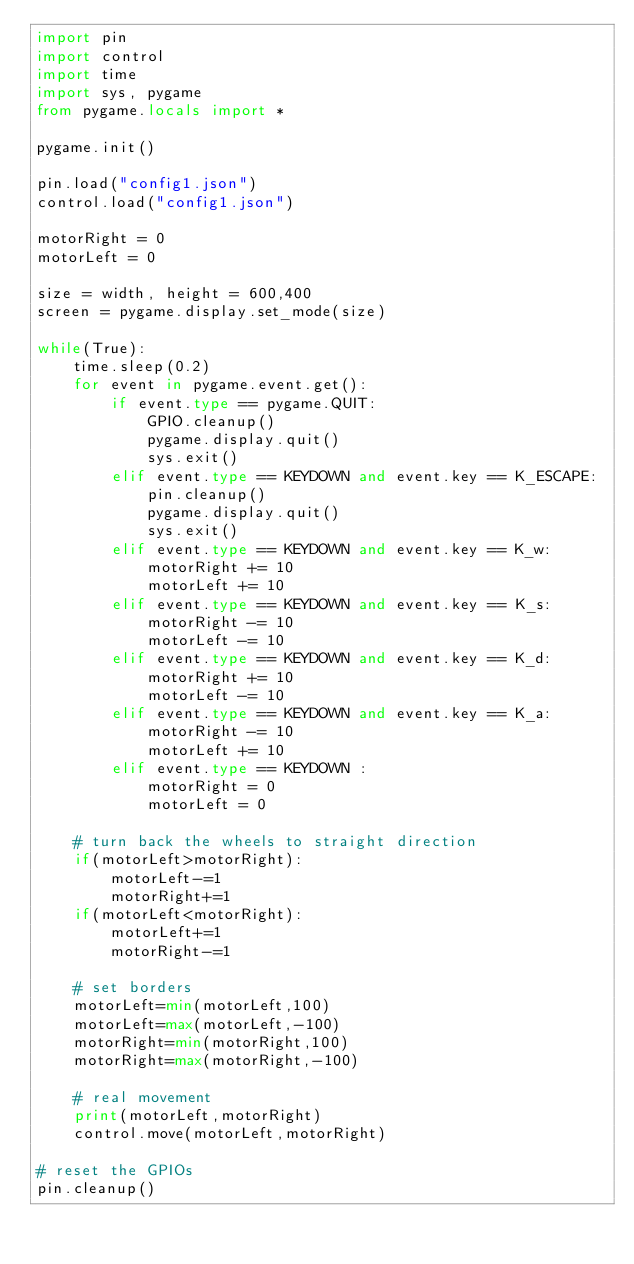<code> <loc_0><loc_0><loc_500><loc_500><_Python_>import pin
import control
import time
import sys, pygame
from pygame.locals import *

pygame.init()

pin.load("config1.json")
control.load("config1.json")

motorRight = 0
motorLeft = 0

size = width, height = 600,400
screen = pygame.display.set_mode(size)

while(True):        
    time.sleep(0.2)
    for event in pygame.event.get():
        if event.type == pygame.QUIT:
            GPIO.cleanup()
            pygame.display.quit()
            sys.exit()           
        elif event.type == KEYDOWN and event.key == K_ESCAPE:            
            pin.cleanup()
            pygame.display.quit()
            sys.exit()            
        elif event.type == KEYDOWN and event.key == K_w:            
            motorRight += 10
            motorLeft += 10
        elif event.type == KEYDOWN and event.key == K_s:            
            motorRight -= 10
            motorLeft -= 10
        elif event.type == KEYDOWN and event.key == K_d:            
            motorRight += 10
            motorLeft -= 10    
        elif event.type == KEYDOWN and event.key == K_a:            
            motorRight -= 10
            motorLeft += 10
        elif event.type == KEYDOWN :            
            motorRight = 0
            motorLeft = 0

    # turn back the wheels to straight direction
    if(motorLeft>motorRight):
        motorLeft-=1
        motorRight+=1
    if(motorLeft<motorRight):
        motorLeft+=1
        motorRight-=1

    # set borders
    motorLeft=min(motorLeft,100)
    motorLeft=max(motorLeft,-100)
    motorRight=min(motorRight,100)
    motorRight=max(motorRight,-100)

    # real movement        
    print(motorLeft,motorRight)
    control.move(motorLeft,motorRight)  
   
# reset the GPIOs
pin.cleanup()
</code> 